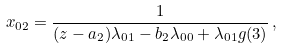<formula> <loc_0><loc_0><loc_500><loc_500>x _ { 0 2 } = \frac { 1 } { ( z - a _ { 2 } ) \lambda _ { 0 1 } - b _ { 2 } \lambda _ { 0 0 } + \lambda _ { 0 1 } g ( 3 ) } \, ,</formula> 